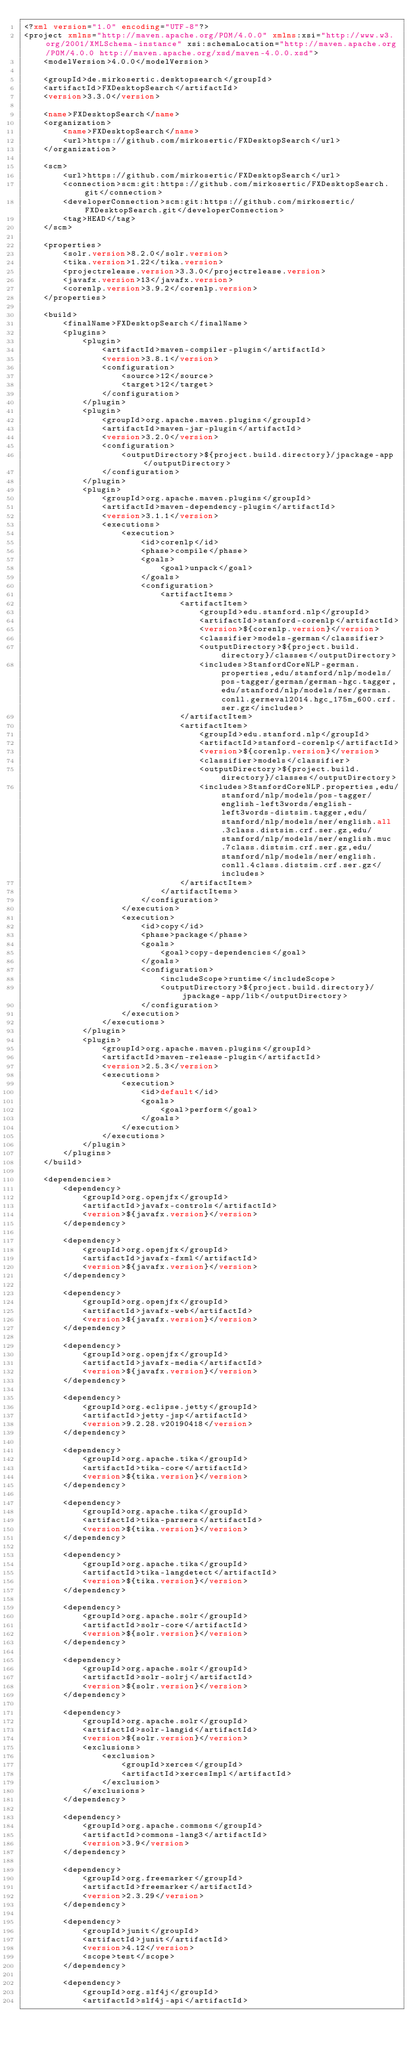Convert code to text. <code><loc_0><loc_0><loc_500><loc_500><_XML_><?xml version="1.0" encoding="UTF-8"?>
<project xmlns="http://maven.apache.org/POM/4.0.0" xmlns:xsi="http://www.w3.org/2001/XMLSchema-instance" xsi:schemaLocation="http://maven.apache.org/POM/4.0.0 http://maven.apache.org/xsd/maven-4.0.0.xsd">
    <modelVersion>4.0.0</modelVersion>

    <groupId>de.mirkosertic.desktopsearch</groupId>
    <artifactId>FXDesktopSearch</artifactId>
    <version>3.3.0</version>

    <name>FXDesktopSearch</name>
    <organization>
        <name>FXDesktopSearch</name>
        <url>https://github.com/mirkosertic/FXDesktopSearch</url>
    </organization>

    <scm>
        <url>https://github.com/mirkosertic/FXDesktopSearch</url>
        <connection>scm:git:https://github.com/mirkosertic/FXDesktopSearch.git</connection>
        <developerConnection>scm:git:https://github.com/mirkosertic/FXDesktopSearch.git</developerConnection>
        <tag>HEAD</tag>
    </scm>

    <properties>
        <solr.version>8.2.0</solr.version>
        <tika.version>1.22</tika.version>
        <projectrelease.version>3.3.0</projectrelease.version>
        <javafx.version>13</javafx.version>
        <corenlp.version>3.9.2</corenlp.version>
    </properties>

    <build>
        <finalName>FXDesktopSearch</finalName>
        <plugins>
            <plugin>
                <artifactId>maven-compiler-plugin</artifactId>
                <version>3.8.1</version>
                <configuration>
                    <source>12</source>
                    <target>12</target>
                </configuration>
            </plugin>
            <plugin>
                <groupId>org.apache.maven.plugins</groupId>
                <artifactId>maven-jar-plugin</artifactId>
                <version>3.2.0</version>
                <configuration>
                    <outputDirectory>${project.build.directory}/jpackage-app</outputDirectory>
                </configuration>
            </plugin>
            <plugin>
                <groupId>org.apache.maven.plugins</groupId>
                <artifactId>maven-dependency-plugin</artifactId>
                <version>3.1.1</version>
                <executions>
                    <execution>
                        <id>corenlp</id>
                        <phase>compile</phase>
                        <goals>
                            <goal>unpack</goal>
                        </goals>
                        <configuration>
                            <artifactItems>
                                <artifactItem>
                                    <groupId>edu.stanford.nlp</groupId>
                                    <artifactId>stanford-corenlp</artifactId>
                                    <version>${corenlp.version}</version>
                                    <classifier>models-german</classifier>
                                    <outputDirectory>${project.build.directory}/classes</outputDirectory>
                                    <includes>StanfordCoreNLP-german.properties,edu/stanford/nlp/models/pos-tagger/german/german-hgc.tagger,edu/stanford/nlp/models/ner/german.conll.germeval2014.hgc_175m_600.crf.ser.gz</includes>
                                </artifactItem>
                                <artifactItem>
                                    <groupId>edu.stanford.nlp</groupId>
                                    <artifactId>stanford-corenlp</artifactId>
                                    <version>${corenlp.version}</version>
                                    <classifier>models</classifier>
                                    <outputDirectory>${project.build.directory}/classes</outputDirectory>
                                    <includes>StanfordCoreNLP.properties,edu/stanford/nlp/models/pos-tagger/english-left3words/english-left3words-distsim.tagger,edu/stanford/nlp/models/ner/english.all.3class.distsim.crf.ser.gz,edu/stanford/nlp/models/ner/english.muc.7class.distsim.crf.ser.gz,edu/stanford/nlp/models/ner/english.conll.4class.distsim.crf.ser.gz</includes>
                                </artifactItem>
                            </artifactItems>
                        </configuration>
                    </execution>
                    <execution>
                        <id>copy</id>
                        <phase>package</phase>
                        <goals>
                            <goal>copy-dependencies</goal>
                        </goals>
                        <configuration>
                            <includeScope>runtime</includeScope>
                            <outputDirectory>${project.build.directory}/jpackage-app/lib</outputDirectory>
                        </configuration>
                    </execution>
                </executions>
            </plugin>
            <plugin>
                <groupId>org.apache.maven.plugins</groupId>
                <artifactId>maven-release-plugin</artifactId>
                <version>2.5.3</version>
                <executions>
                    <execution>
                        <id>default</id>
                        <goals>
                            <goal>perform</goal>
                        </goals>
                    </execution>
                </executions>
            </plugin>
        </plugins>
    </build>

    <dependencies>
        <dependency>
            <groupId>org.openjfx</groupId>
            <artifactId>javafx-controls</artifactId>
            <version>${javafx.version}</version>
        </dependency>

        <dependency>
            <groupId>org.openjfx</groupId>
            <artifactId>javafx-fxml</artifactId>
            <version>${javafx.version}</version>
        </dependency>

        <dependency>
            <groupId>org.openjfx</groupId>
            <artifactId>javafx-web</artifactId>
            <version>${javafx.version}</version>
        </dependency>

        <dependency>
            <groupId>org.openjfx</groupId>
            <artifactId>javafx-media</artifactId>
            <version>${javafx.version}</version>
        </dependency>

        <dependency>
            <groupId>org.eclipse.jetty</groupId>
            <artifactId>jetty-jsp</artifactId>
            <version>9.2.28.v20190418</version>
        </dependency>

        <dependency>
            <groupId>org.apache.tika</groupId>
            <artifactId>tika-core</artifactId>
            <version>${tika.version}</version>
        </dependency>

        <dependency>
            <groupId>org.apache.tika</groupId>
            <artifactId>tika-parsers</artifactId>
            <version>${tika.version}</version>
        </dependency>

        <dependency>
            <groupId>org.apache.tika</groupId>
            <artifactId>tika-langdetect</artifactId>
            <version>${tika.version}</version>
        </dependency>

        <dependency>
            <groupId>org.apache.solr</groupId>
            <artifactId>solr-core</artifactId>
            <version>${solr.version}</version>
        </dependency>

        <dependency>
            <groupId>org.apache.solr</groupId>
            <artifactId>solr-solrj</artifactId>
            <version>${solr.version}</version>
        </dependency>

        <dependency>
            <groupId>org.apache.solr</groupId>
            <artifactId>solr-langid</artifactId>
            <version>${solr.version}</version>
            <exclusions>
                <exclusion>
                    <groupId>xerces</groupId>
                    <artifactId>xercesImpl</artifactId>
                </exclusion>
            </exclusions>
        </dependency>

        <dependency>
            <groupId>org.apache.commons</groupId>
            <artifactId>commons-lang3</artifactId>
            <version>3.9</version>
        </dependency>

        <dependency>
            <groupId>org.freemarker</groupId>
            <artifactId>freemarker</artifactId>
            <version>2.3.29</version>
        </dependency>

        <dependency>
            <groupId>junit</groupId>
            <artifactId>junit</artifactId>
            <version>4.12</version>
            <scope>test</scope>
        </dependency>

        <dependency>
            <groupId>org.slf4j</groupId>
            <artifactId>slf4j-api</artifactId></code> 